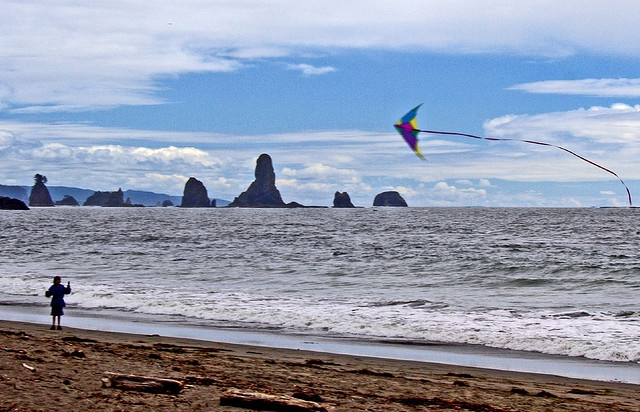Describe the objects in this image and their specific colors. I can see people in lavender, black, navy, gray, and darkgray tones and kite in lavender, blue, purple, navy, and teal tones in this image. 